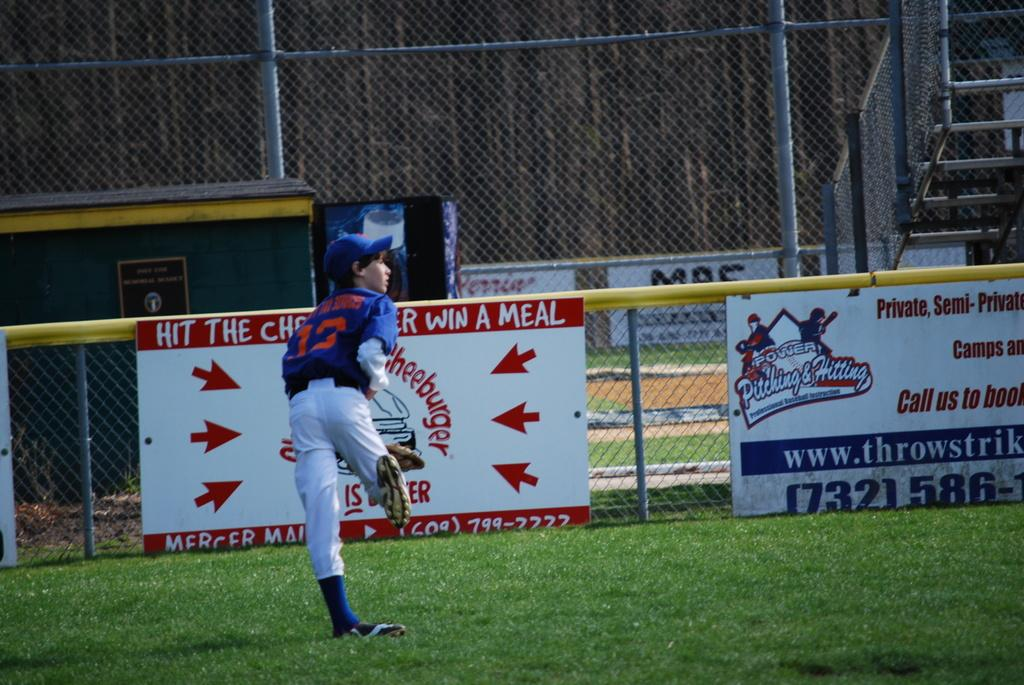<image>
Write a terse but informative summary of the picture. A young baseball player wearing the number 13 jersey runs in the outfield. 